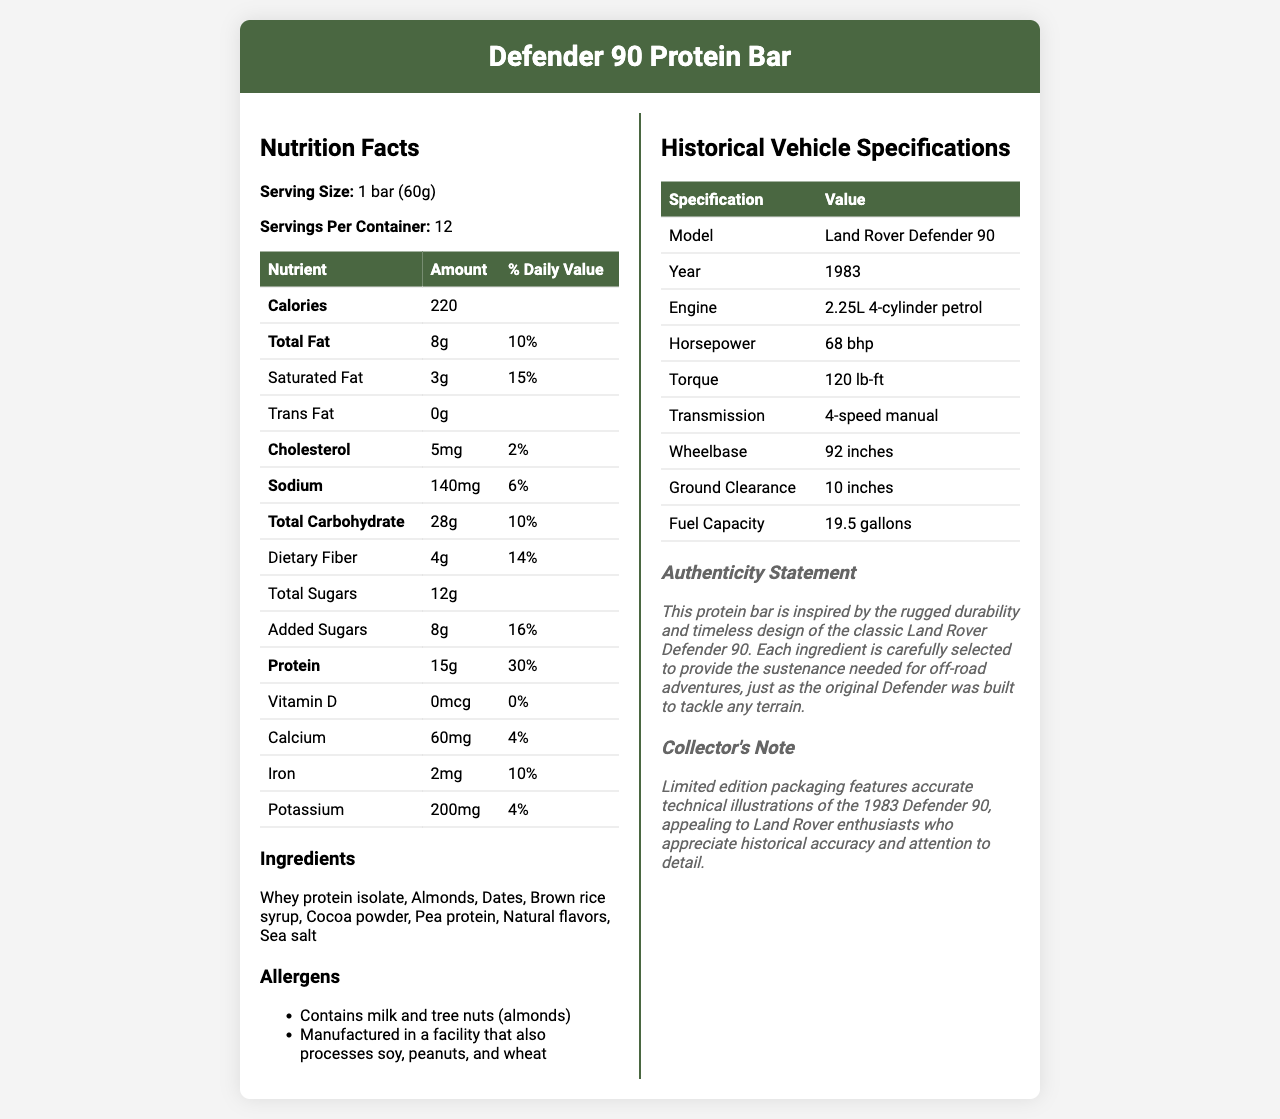what is the serving size of the Defender 90 Protein Bar? The serving size is clearly stated at the beginning of the Nutrition Facts section as "1 bar (60g)."
Answer: 1 bar (60g) how many servings are there per container? The number of servings per container is explicitly listed at the beginning of the Nutrition Facts section as "Servings Per Container: 12."
Answer: 12 how much protein does one Defender 90 Protein Bar provide? The document lists the protein content directly in the Nutrition Facts table with "Protein: 15g."
Answer: 15g what is the model year of the Land Rover Defender 90 featured on the packaging? The Historical Vehicle Specifications section specifies that the model year of the Land Rover Defender 90 is 1983.
Answer: 1983 how many calories are in one serving of the Defender 90 Protein Bar? The Nutrition Facts table specifies that each serving contains 220 calories.
Answer: 220 how much saturated fat is in one serving of the protein bar? The Nutrition Facts table indicates that the saturated fat content per serving is 3g.
Answer: 3g what allergens does the Defender 90 Protein Bar contain? The Allergens section lists "Contains milk and tree nuts (almonds)" explicitly.
Answer: milk and tree nuts (almonds) how much dietary fiber is in one serving of the protein bar? The dietary fiber content per serving is provided as 4g in the Nutrition Facts table.
Answer: 4g what percentage of daily value is the added sugars in one serving? The Nutrition Facts table indicates the daily value percentage for added sugars as 16%.
Answer: 16% which of the following is not an ingredient in the Defender 90 Protein Bar? A. Whey protein isolate B. Cocoa powder C. Soy protein D. Almonds The Ingredients section lists whey protein isolate, cocoa powder, and almonds but does not list soy protein.
Answer: C what is the ground clearance of the Land Rover Defender 90? A. 8 inches B. 10 inches C. 12 inches D. 15 inches The Historical Vehicle Specifications table states the ground clearance of the Land Rover Defender 90 is 10 inches.
Answer: B does the Defender 90 Protein Bar contain any trans fat? The document explicitly states that the trans fat content in one serving of the protein bar is 0g.
Answer: No summarize the main idea of the document The document is divided into sections that detail the nutritional content and ingredients of the protein bar and the historical specifications of the 1983 Land Rover Defender 90. It aims to connect the rugged and durable image of the classic vehicle with the protein bar, making it attractive to collectors and enthusiasts.
Answer: The document provides the nutritional information, ingredient list, allergens, and historical vehicle specifications of the Land Rover Defender 90-themed protein bar, along with an authenticity statement and a collector's note emphasizing the historical accuracy and appeal to Land Rover enthusiasts. how much total fat is in the protein bar per serving, and what is its % daily value? The Nutrition Facts table lists total fat content as 8g per serving with a daily value of 10%.
Answer: 8g, 10% what is the fuel capacity of the Land Rover Defender 90 featured? The Historical Vehicle Specifications table mentions the fuel capacity as 19.5 gallons.
Answer: 19.5 gallons how many different ingredients are listed for the Defender 90 Protein Bar? The Ingredients section lists whey protein isolate, almonds, dates, brown rice syrup, cocoa powder, pea protein, natural flavors, and sea salt, making a total of 8 ingredients.
Answer: 8 what is the weight of this protein bar? The Serving Size section states that one bar weighs 60 grams.
Answer: 60g is the facility where the protein bar is manufactured free from peanuts? The Allergens section mentions that the bar is manufactured in a facility that also processes peanuts.
Answer: No by how much horsepower does the engine of the Land Rover Defender 90 offer? A. 50 bhp B. 68 bhp C. 80 bhp The Historical Vehicle Specifications section lists the engine's horsepower as 68 bhp.
Answer: B what are the main points of the authenticity statement? The authenticity statement emphasizes the protein bar's inspiration from the rugged and durable design of the Land Rover Defender 90, with carefully selected ingredients to support off-road adventures.
Answer: Inspired by the rugged durability and timeless design of the classic Land Rover Defender 90, using selected ingredients for off-road adventures. what is the transmission type of the Land Rover Defender 90? The Historical Vehicle Specifications section specifies the transmission type as a 4-speed manual.
Answer: 4-speed manual what specific engine does the classic Land Rover Defender 90 use? The Historical Vehicle Specifications section provides the engine details as "2.25L 4-cylinder petrol."
Answer: 2.25L 4-cylinder petrol where else could these protein bars most likely be manufactured? The document does not provide information about other manufacturing locations for the protein bars.
Answer: Cannot be determined 